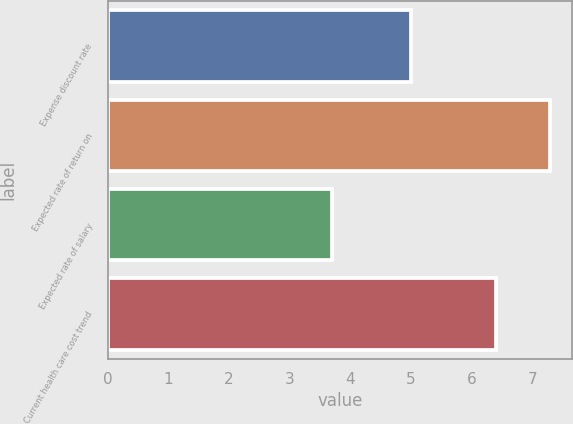<chart> <loc_0><loc_0><loc_500><loc_500><bar_chart><fcel>Expense discount rate<fcel>Expected rate of return on<fcel>Expected rate of salary<fcel>Current health care cost trend<nl><fcel>5<fcel>7.3<fcel>3.7<fcel>6.4<nl></chart> 